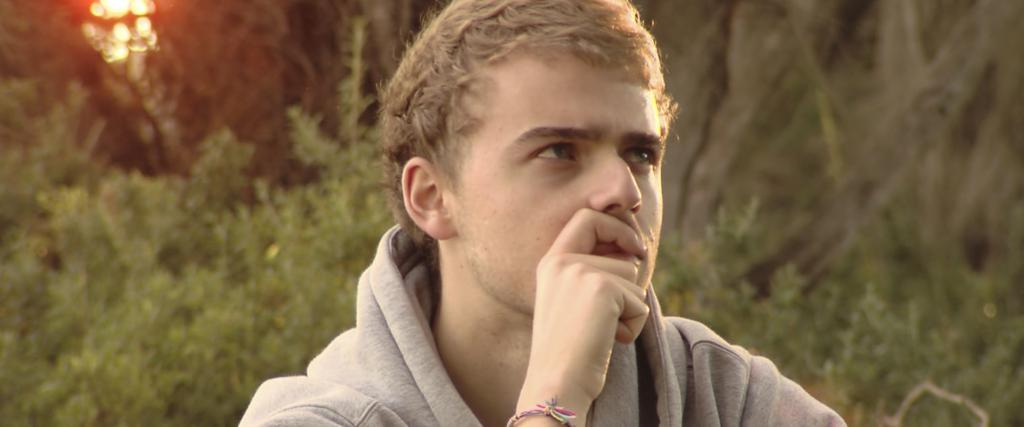Who is the main subject in the foreground of the picture? There is a man in the foreground of the picture. What is the man wearing in the image? The man is wearing a hoodie. What can be seen in the background of the image? There are plants and trees in the background of the image. What is the condition of the sky in the image? The sun is shining at the top of the image. How many blades are visible on the ball in the image? There is no ball or blade present in the image. What type of fifth object can be seen in the image? There is no fifth object mentioned in the provided facts, and the image only contains a man, plants, trees, and a sunny sky. 